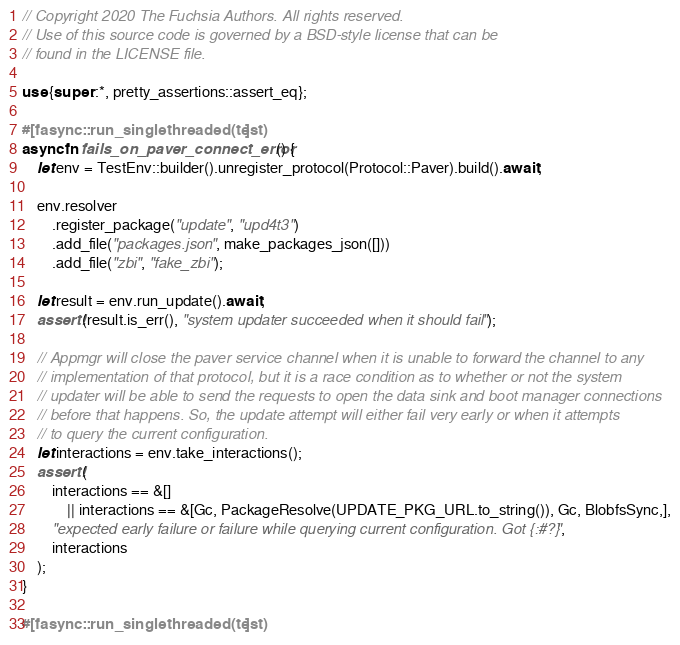<code> <loc_0><loc_0><loc_500><loc_500><_Rust_>// Copyright 2020 The Fuchsia Authors. All rights reserved.
// Use of this source code is governed by a BSD-style license that can be
// found in the LICENSE file.

use {super::*, pretty_assertions::assert_eq};

#[fasync::run_singlethreaded(test)]
async fn fails_on_paver_connect_error() {
    let env = TestEnv::builder().unregister_protocol(Protocol::Paver).build().await;

    env.resolver
        .register_package("update", "upd4t3")
        .add_file("packages.json", make_packages_json([]))
        .add_file("zbi", "fake_zbi");

    let result = env.run_update().await;
    assert!(result.is_err(), "system updater succeeded when it should fail");

    // Appmgr will close the paver service channel when it is unable to forward the channel to any
    // implementation of that protocol, but it is a race condition as to whether or not the system
    // updater will be able to send the requests to open the data sink and boot manager connections
    // before that happens. So, the update attempt will either fail very early or when it attempts
    // to query the current configuration.
    let interactions = env.take_interactions();
    assert!(
        interactions == &[]
            || interactions == &[Gc, PackageResolve(UPDATE_PKG_URL.to_string()), Gc, BlobfsSync,],
        "expected early failure or failure while querying current configuration. Got {:#?}",
        interactions
    );
}

#[fasync::run_singlethreaded(test)]</code> 